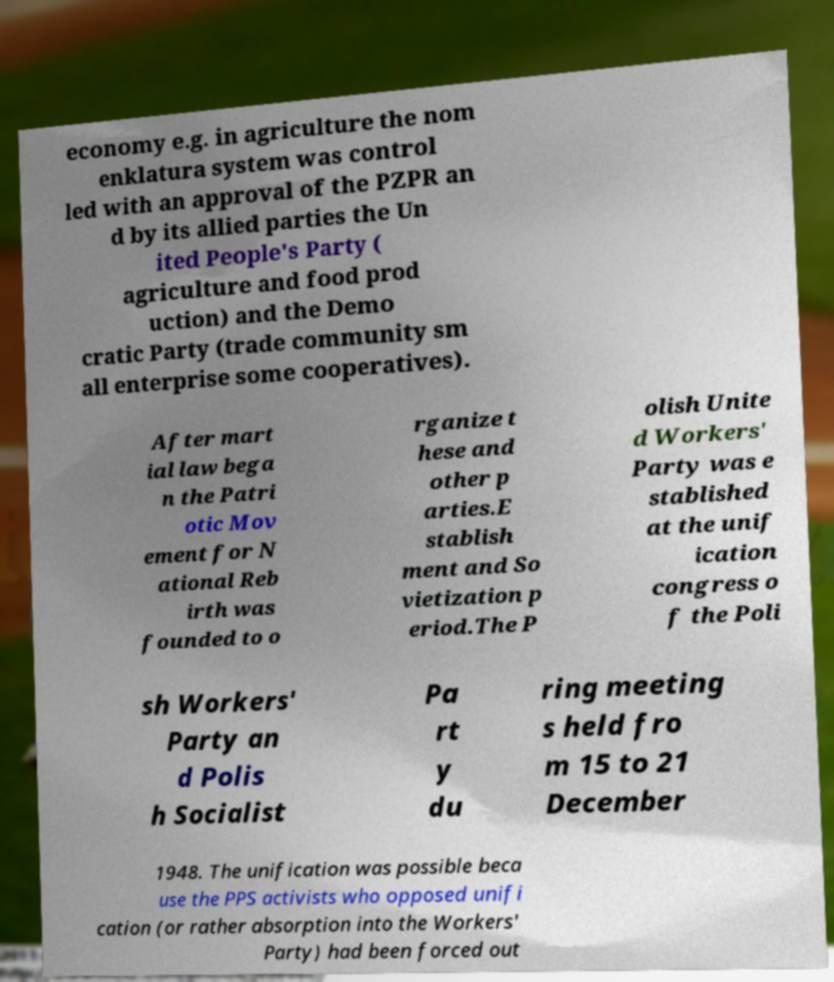Can you read and provide the text displayed in the image?This photo seems to have some interesting text. Can you extract and type it out for me? economy e.g. in agriculture the nom enklatura system was control led with an approval of the PZPR an d by its allied parties the Un ited People's Party ( agriculture and food prod uction) and the Demo cratic Party (trade community sm all enterprise some cooperatives). After mart ial law bega n the Patri otic Mov ement for N ational Reb irth was founded to o rganize t hese and other p arties.E stablish ment and So vietization p eriod.The P olish Unite d Workers' Party was e stablished at the unif ication congress o f the Poli sh Workers' Party an d Polis h Socialist Pa rt y du ring meeting s held fro m 15 to 21 December 1948. The unification was possible beca use the PPS activists who opposed unifi cation (or rather absorption into the Workers' Party) had been forced out 